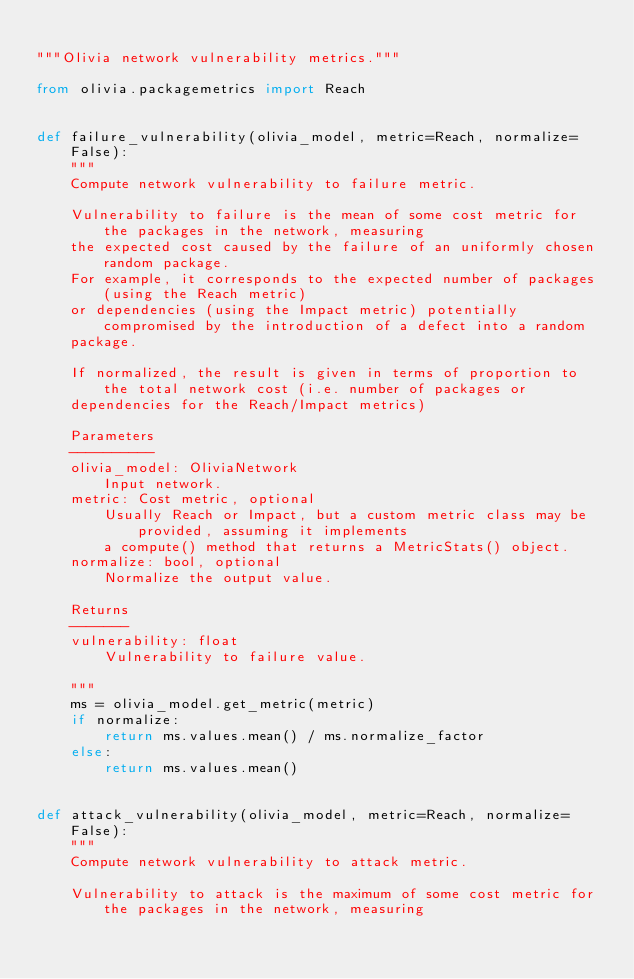Convert code to text. <code><loc_0><loc_0><loc_500><loc_500><_Python_>
"""Olivia network vulnerability metrics."""

from olivia.packagemetrics import Reach


def failure_vulnerability(olivia_model, metric=Reach, normalize=False):
    """
    Compute network vulnerability to failure metric.

    Vulnerability to failure is the mean of some cost metric for the packages in the network, measuring
    the expected cost caused by the failure of an uniformly chosen random package.
    For example, it corresponds to the expected number of packages (using the Reach metric)
    or dependencies (using the Impact metric) potentially compromised by the introduction of a defect into a random
    package.

    If normalized, the result is given in terms of proportion to the total network cost (i.e. number of packages or
    dependencies for the Reach/Impact metrics)

    Parameters
    ----------
    olivia_model: OliviaNetwork
        Input network.
    metric: Cost metric, optional
        Usually Reach or Impact, but a custom metric class may be provided, assuming it implements
        a compute() method that returns a MetricStats() object.
    normalize: bool, optional
        Normalize the output value.

    Returns
    -------
    vulnerability: float
        Vulnerability to failure value.

    """
    ms = olivia_model.get_metric(metric)
    if normalize:
        return ms.values.mean() / ms.normalize_factor
    else:
        return ms.values.mean()


def attack_vulnerability(olivia_model, metric=Reach, normalize=False):
    """
    Compute network vulnerability to attack metric.

    Vulnerability to attack is the maximum of some cost metric for the packages in the network, measuring</code> 